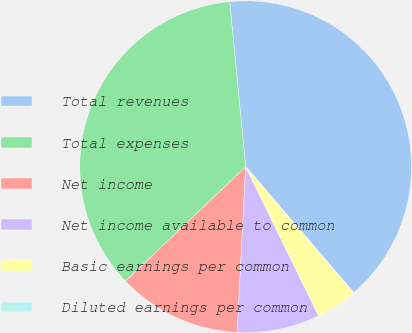<chart> <loc_0><loc_0><loc_500><loc_500><pie_chart><fcel>Total revenues<fcel>Total expenses<fcel>Net income<fcel>Net income available to common<fcel>Basic earnings per common<fcel>Diluted earnings per common<nl><fcel>40.24%<fcel>35.57%<fcel>12.08%<fcel>8.06%<fcel>4.03%<fcel>0.01%<nl></chart> 